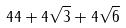<formula> <loc_0><loc_0><loc_500><loc_500>4 4 + 4 \sqrt { 3 } + 4 \sqrt { 6 }</formula> 